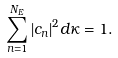Convert formula to latex. <formula><loc_0><loc_0><loc_500><loc_500>\sum _ { n = 1 } ^ { N _ { E } } | c _ { n } | ^ { 2 } d \kappa = 1 .</formula> 